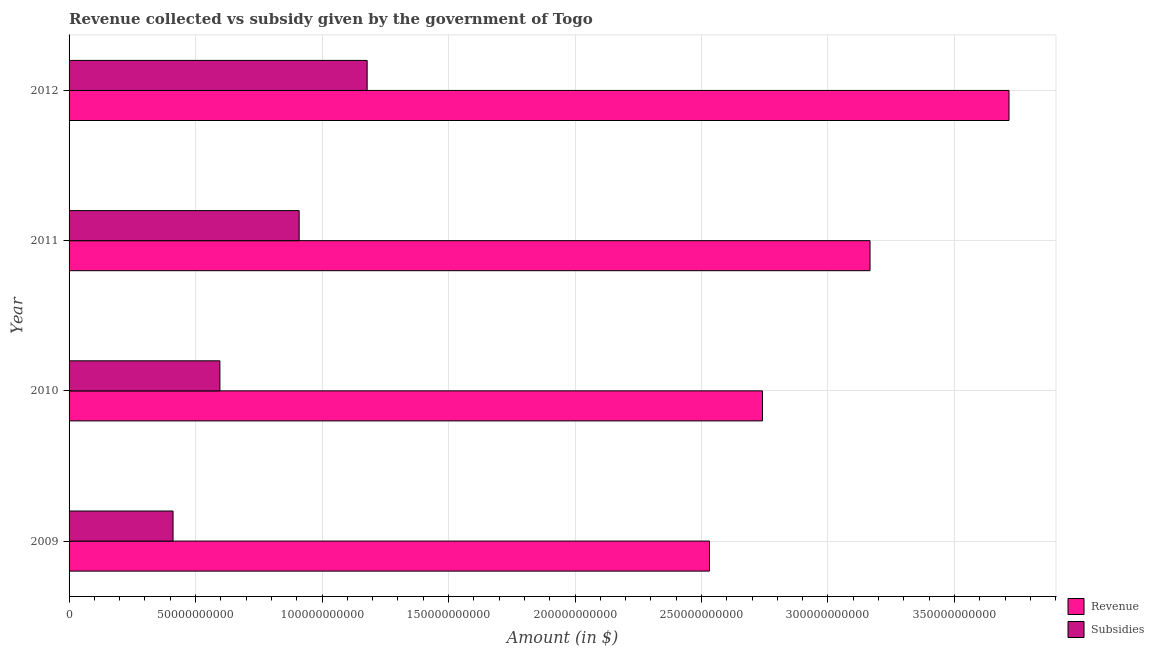How many different coloured bars are there?
Your answer should be very brief. 2. Are the number of bars per tick equal to the number of legend labels?
Your response must be concise. Yes. Are the number of bars on each tick of the Y-axis equal?
Your answer should be very brief. Yes. How many bars are there on the 4th tick from the top?
Offer a very short reply. 2. What is the amount of revenue collected in 2012?
Ensure brevity in your answer.  3.72e+11. Across all years, what is the maximum amount of subsidies given?
Make the answer very short. 1.18e+11. Across all years, what is the minimum amount of revenue collected?
Make the answer very short. 2.53e+11. What is the total amount of revenue collected in the graph?
Provide a succinct answer. 1.22e+12. What is the difference between the amount of revenue collected in 2010 and that in 2011?
Offer a very short reply. -4.25e+1. What is the difference between the amount of revenue collected in 2010 and the amount of subsidies given in 2011?
Provide a succinct answer. 1.83e+11. What is the average amount of revenue collected per year?
Offer a terse response. 3.04e+11. In the year 2011, what is the difference between the amount of subsidies given and amount of revenue collected?
Your answer should be compact. -2.26e+11. In how many years, is the amount of revenue collected greater than 300000000000 $?
Offer a terse response. 2. What is the ratio of the amount of subsidies given in 2010 to that in 2011?
Provide a succinct answer. 0.66. What is the difference between the highest and the second highest amount of revenue collected?
Provide a short and direct response. 5.49e+1. What is the difference between the highest and the lowest amount of subsidies given?
Provide a short and direct response. 7.67e+1. What does the 2nd bar from the top in 2009 represents?
Ensure brevity in your answer.  Revenue. What does the 1st bar from the bottom in 2012 represents?
Your answer should be very brief. Revenue. Are all the bars in the graph horizontal?
Keep it short and to the point. Yes. Are the values on the major ticks of X-axis written in scientific E-notation?
Offer a very short reply. No. What is the title of the graph?
Your response must be concise. Revenue collected vs subsidy given by the government of Togo. Does "Males" appear as one of the legend labels in the graph?
Make the answer very short. No. What is the label or title of the X-axis?
Provide a succinct answer. Amount (in $). What is the label or title of the Y-axis?
Offer a very short reply. Year. What is the Amount (in $) in Revenue in 2009?
Your answer should be compact. 2.53e+11. What is the Amount (in $) in Subsidies in 2009?
Provide a succinct answer. 4.11e+1. What is the Amount (in $) of Revenue in 2010?
Offer a very short reply. 2.74e+11. What is the Amount (in $) in Subsidies in 2010?
Make the answer very short. 5.96e+1. What is the Amount (in $) of Revenue in 2011?
Offer a terse response. 3.17e+11. What is the Amount (in $) of Subsidies in 2011?
Make the answer very short. 9.10e+1. What is the Amount (in $) of Revenue in 2012?
Your answer should be compact. 3.72e+11. What is the Amount (in $) in Subsidies in 2012?
Your response must be concise. 1.18e+11. Across all years, what is the maximum Amount (in $) in Revenue?
Your response must be concise. 3.72e+11. Across all years, what is the maximum Amount (in $) of Subsidies?
Ensure brevity in your answer.  1.18e+11. Across all years, what is the minimum Amount (in $) in Revenue?
Give a very brief answer. 2.53e+11. Across all years, what is the minimum Amount (in $) in Subsidies?
Ensure brevity in your answer.  4.11e+1. What is the total Amount (in $) in Revenue in the graph?
Ensure brevity in your answer.  1.22e+12. What is the total Amount (in $) of Subsidies in the graph?
Provide a succinct answer. 3.10e+11. What is the difference between the Amount (in $) in Revenue in 2009 and that in 2010?
Ensure brevity in your answer.  -2.10e+1. What is the difference between the Amount (in $) in Subsidies in 2009 and that in 2010?
Keep it short and to the point. -1.85e+1. What is the difference between the Amount (in $) of Revenue in 2009 and that in 2011?
Give a very brief answer. -6.35e+1. What is the difference between the Amount (in $) of Subsidies in 2009 and that in 2011?
Keep it short and to the point. -4.99e+1. What is the difference between the Amount (in $) of Revenue in 2009 and that in 2012?
Keep it short and to the point. -1.18e+11. What is the difference between the Amount (in $) in Subsidies in 2009 and that in 2012?
Your response must be concise. -7.67e+1. What is the difference between the Amount (in $) in Revenue in 2010 and that in 2011?
Offer a very short reply. -4.25e+1. What is the difference between the Amount (in $) of Subsidies in 2010 and that in 2011?
Provide a succinct answer. -3.13e+1. What is the difference between the Amount (in $) in Revenue in 2010 and that in 2012?
Ensure brevity in your answer.  -9.74e+1. What is the difference between the Amount (in $) in Subsidies in 2010 and that in 2012?
Your response must be concise. -5.82e+1. What is the difference between the Amount (in $) in Revenue in 2011 and that in 2012?
Offer a terse response. -5.49e+1. What is the difference between the Amount (in $) of Subsidies in 2011 and that in 2012?
Your response must be concise. -2.69e+1. What is the difference between the Amount (in $) of Revenue in 2009 and the Amount (in $) of Subsidies in 2010?
Your response must be concise. 1.94e+11. What is the difference between the Amount (in $) of Revenue in 2009 and the Amount (in $) of Subsidies in 2011?
Your response must be concise. 1.62e+11. What is the difference between the Amount (in $) of Revenue in 2009 and the Amount (in $) of Subsidies in 2012?
Give a very brief answer. 1.35e+11. What is the difference between the Amount (in $) of Revenue in 2010 and the Amount (in $) of Subsidies in 2011?
Offer a very short reply. 1.83e+11. What is the difference between the Amount (in $) of Revenue in 2010 and the Amount (in $) of Subsidies in 2012?
Keep it short and to the point. 1.56e+11. What is the difference between the Amount (in $) of Revenue in 2011 and the Amount (in $) of Subsidies in 2012?
Provide a succinct answer. 1.99e+11. What is the average Amount (in $) of Revenue per year?
Offer a very short reply. 3.04e+11. What is the average Amount (in $) in Subsidies per year?
Give a very brief answer. 7.74e+1. In the year 2009, what is the difference between the Amount (in $) of Revenue and Amount (in $) of Subsidies?
Make the answer very short. 2.12e+11. In the year 2010, what is the difference between the Amount (in $) of Revenue and Amount (in $) of Subsidies?
Your response must be concise. 2.15e+11. In the year 2011, what is the difference between the Amount (in $) of Revenue and Amount (in $) of Subsidies?
Make the answer very short. 2.26e+11. In the year 2012, what is the difference between the Amount (in $) of Revenue and Amount (in $) of Subsidies?
Your response must be concise. 2.54e+11. What is the ratio of the Amount (in $) of Revenue in 2009 to that in 2010?
Your response must be concise. 0.92. What is the ratio of the Amount (in $) in Subsidies in 2009 to that in 2010?
Offer a very short reply. 0.69. What is the ratio of the Amount (in $) of Revenue in 2009 to that in 2011?
Offer a very short reply. 0.8. What is the ratio of the Amount (in $) in Subsidies in 2009 to that in 2011?
Make the answer very short. 0.45. What is the ratio of the Amount (in $) of Revenue in 2009 to that in 2012?
Offer a terse response. 0.68. What is the ratio of the Amount (in $) of Subsidies in 2009 to that in 2012?
Your answer should be very brief. 0.35. What is the ratio of the Amount (in $) of Revenue in 2010 to that in 2011?
Provide a succinct answer. 0.87. What is the ratio of the Amount (in $) of Subsidies in 2010 to that in 2011?
Your answer should be very brief. 0.66. What is the ratio of the Amount (in $) in Revenue in 2010 to that in 2012?
Make the answer very short. 0.74. What is the ratio of the Amount (in $) of Subsidies in 2010 to that in 2012?
Provide a short and direct response. 0.51. What is the ratio of the Amount (in $) in Revenue in 2011 to that in 2012?
Offer a terse response. 0.85. What is the ratio of the Amount (in $) of Subsidies in 2011 to that in 2012?
Your answer should be very brief. 0.77. What is the difference between the highest and the second highest Amount (in $) in Revenue?
Your response must be concise. 5.49e+1. What is the difference between the highest and the second highest Amount (in $) in Subsidies?
Keep it short and to the point. 2.69e+1. What is the difference between the highest and the lowest Amount (in $) in Revenue?
Ensure brevity in your answer.  1.18e+11. What is the difference between the highest and the lowest Amount (in $) of Subsidies?
Ensure brevity in your answer.  7.67e+1. 